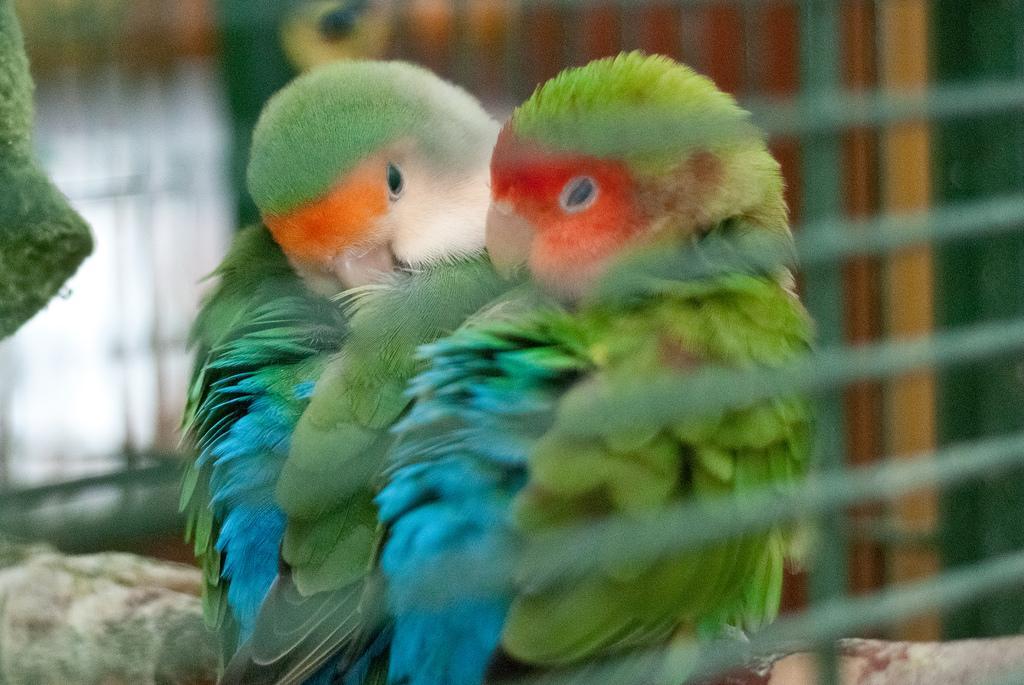How would you summarize this image in a sentence or two? In this image I can see two birds, they are in green, blue and orange color and I can see blurred background. 